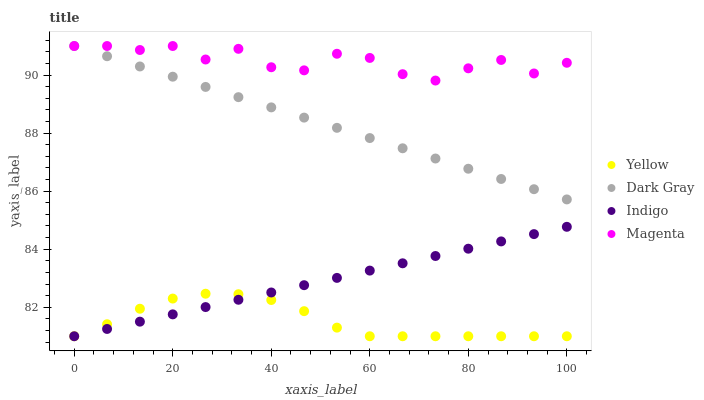Does Yellow have the minimum area under the curve?
Answer yes or no. Yes. Does Magenta have the maximum area under the curve?
Answer yes or no. Yes. Does Indigo have the minimum area under the curve?
Answer yes or no. No. Does Indigo have the maximum area under the curve?
Answer yes or no. No. Is Indigo the smoothest?
Answer yes or no. Yes. Is Magenta the roughest?
Answer yes or no. Yes. Is Magenta the smoothest?
Answer yes or no. No. Is Indigo the roughest?
Answer yes or no. No. Does Indigo have the lowest value?
Answer yes or no. Yes. Does Magenta have the lowest value?
Answer yes or no. No. Does Magenta have the highest value?
Answer yes or no. Yes. Does Indigo have the highest value?
Answer yes or no. No. Is Indigo less than Dark Gray?
Answer yes or no. Yes. Is Dark Gray greater than Yellow?
Answer yes or no. Yes. Does Yellow intersect Indigo?
Answer yes or no. Yes. Is Yellow less than Indigo?
Answer yes or no. No. Is Yellow greater than Indigo?
Answer yes or no. No. Does Indigo intersect Dark Gray?
Answer yes or no. No. 